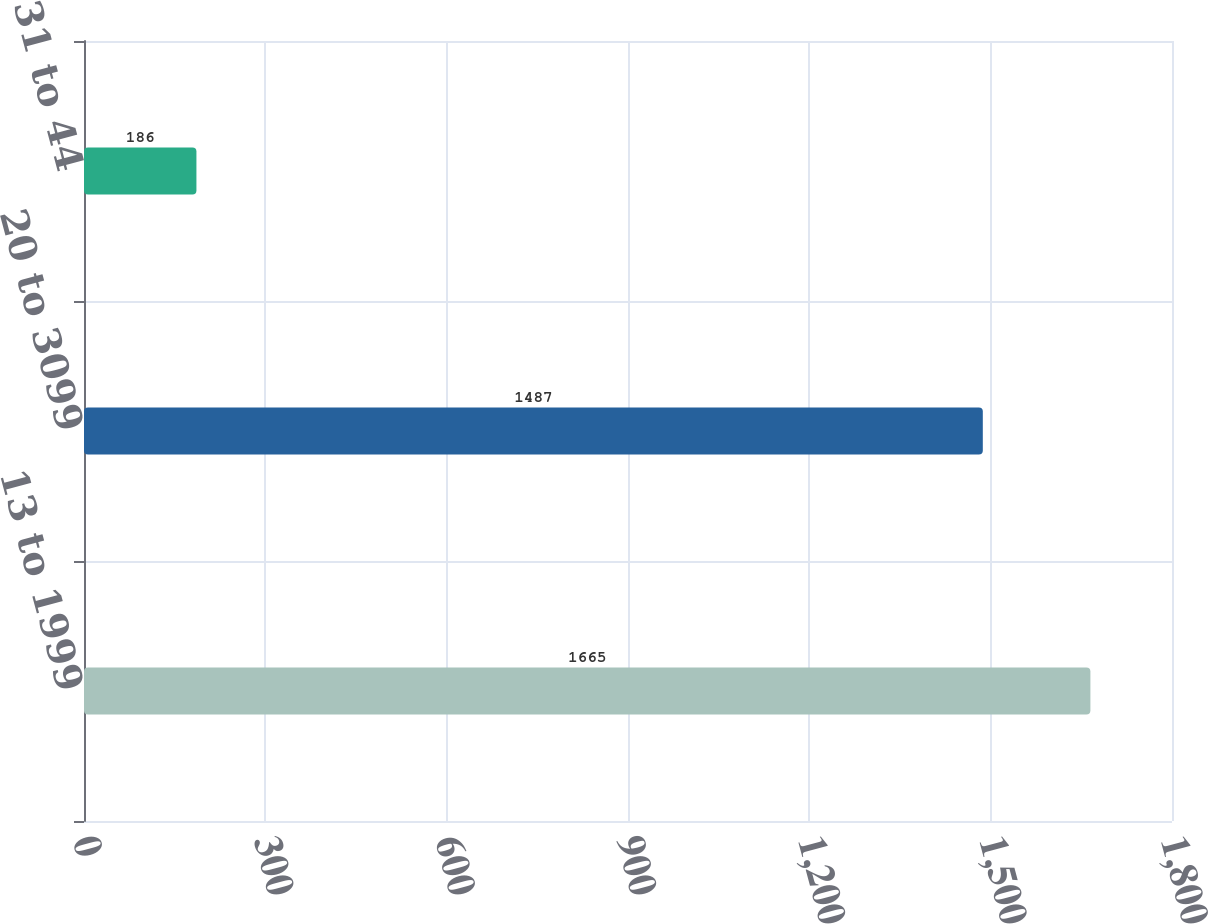Convert chart to OTSL. <chart><loc_0><loc_0><loc_500><loc_500><bar_chart><fcel>13 to 1999<fcel>20 to 3099<fcel>31 to 44<nl><fcel>1665<fcel>1487<fcel>186<nl></chart> 